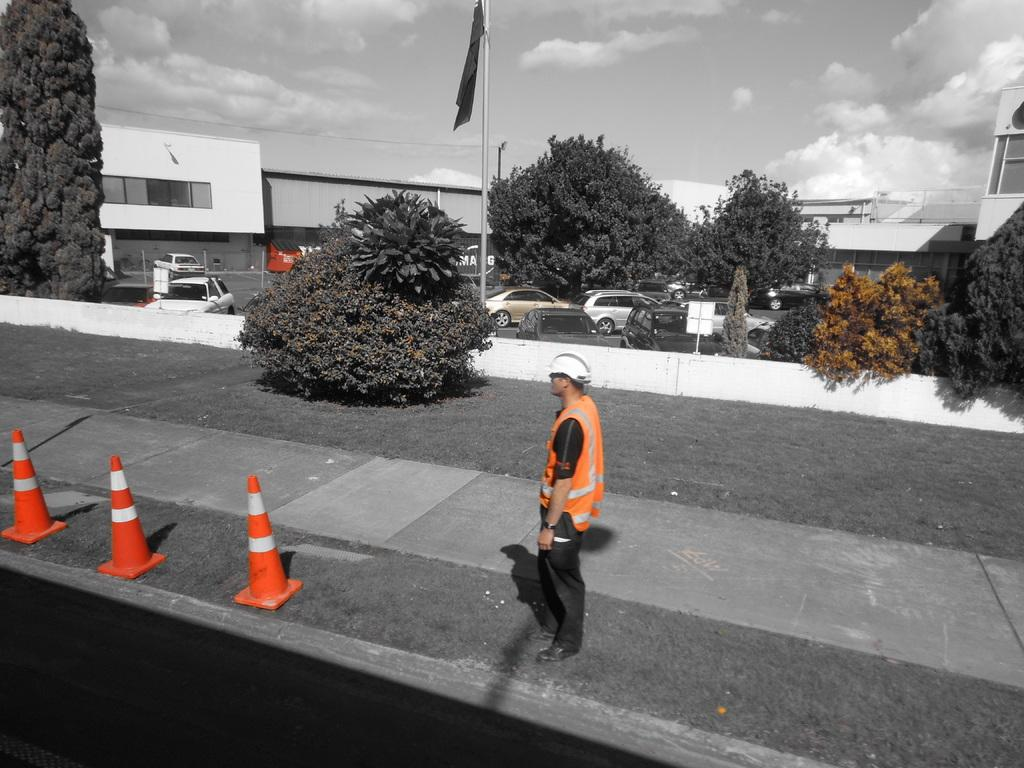What is the main subject of the image? There is a person standing in the image. Can you describe the person's attire? The person is wearing clothes, shoes, and a helmet. What objects are present in the image that might indicate a construction or work zone? There are road cones, a pole, and a flag in the image. What type of structure can be seen in the background? There is a building in the image. What is the weather like in the image? The sky is cloudy in the image. How many pickles can be seen hanging from the pole in the image? There are no pickles present in the image; the pole has a flag attached to it. Can you describe the person's wings in the image? There are no wings visible on the person in the image; they are wearing a helmet, clothes, and shoes. 